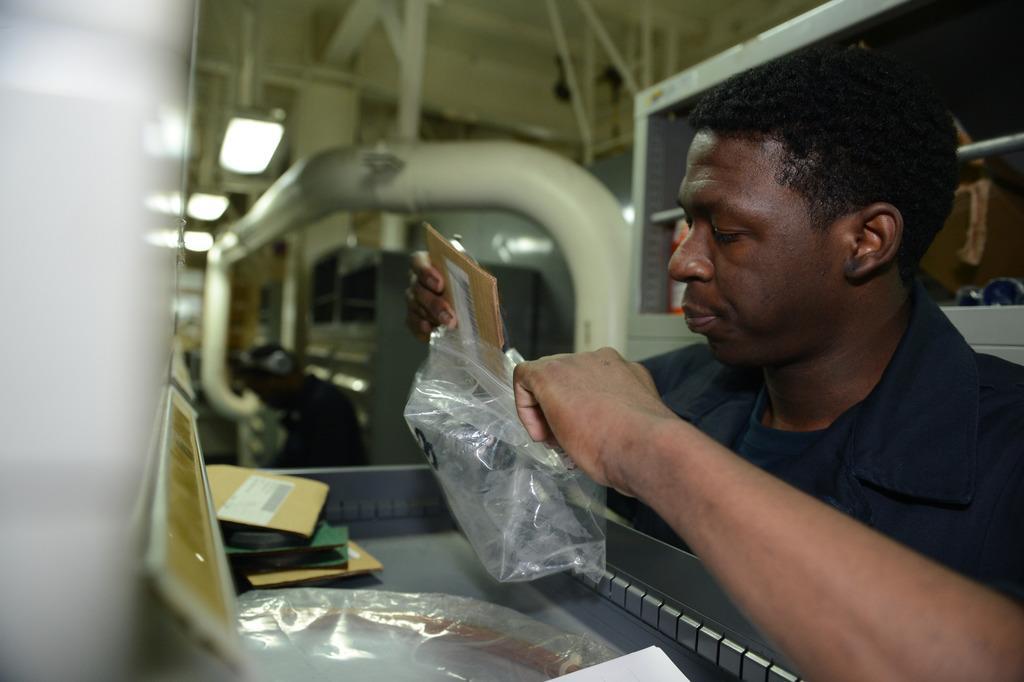How would you summarize this image in a sentence or two? In this picture I can see there is a person sitting and he is holding a bag, there are few objects placed on the table and there are few lights attached to the ceiling, there are few iron frames and the backdrop of the image is a bit blurred. 